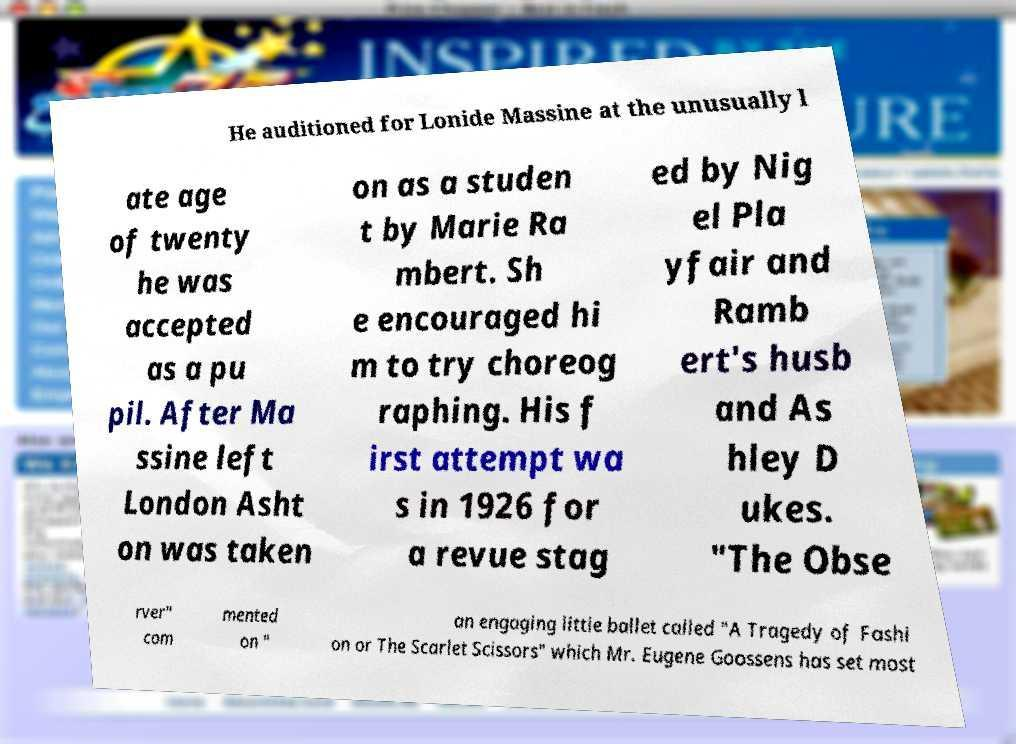Please identify and transcribe the text found in this image. He auditioned for Lonide Massine at the unusually l ate age of twenty he was accepted as a pu pil. After Ma ssine left London Asht on was taken on as a studen t by Marie Ra mbert. Sh e encouraged hi m to try choreog raphing. His f irst attempt wa s in 1926 for a revue stag ed by Nig el Pla yfair and Ramb ert's husb and As hley D ukes. "The Obse rver" com mented on " an engaging little ballet called "A Tragedy of Fashi on or The Scarlet Scissors" which Mr. Eugene Goossens has set most 